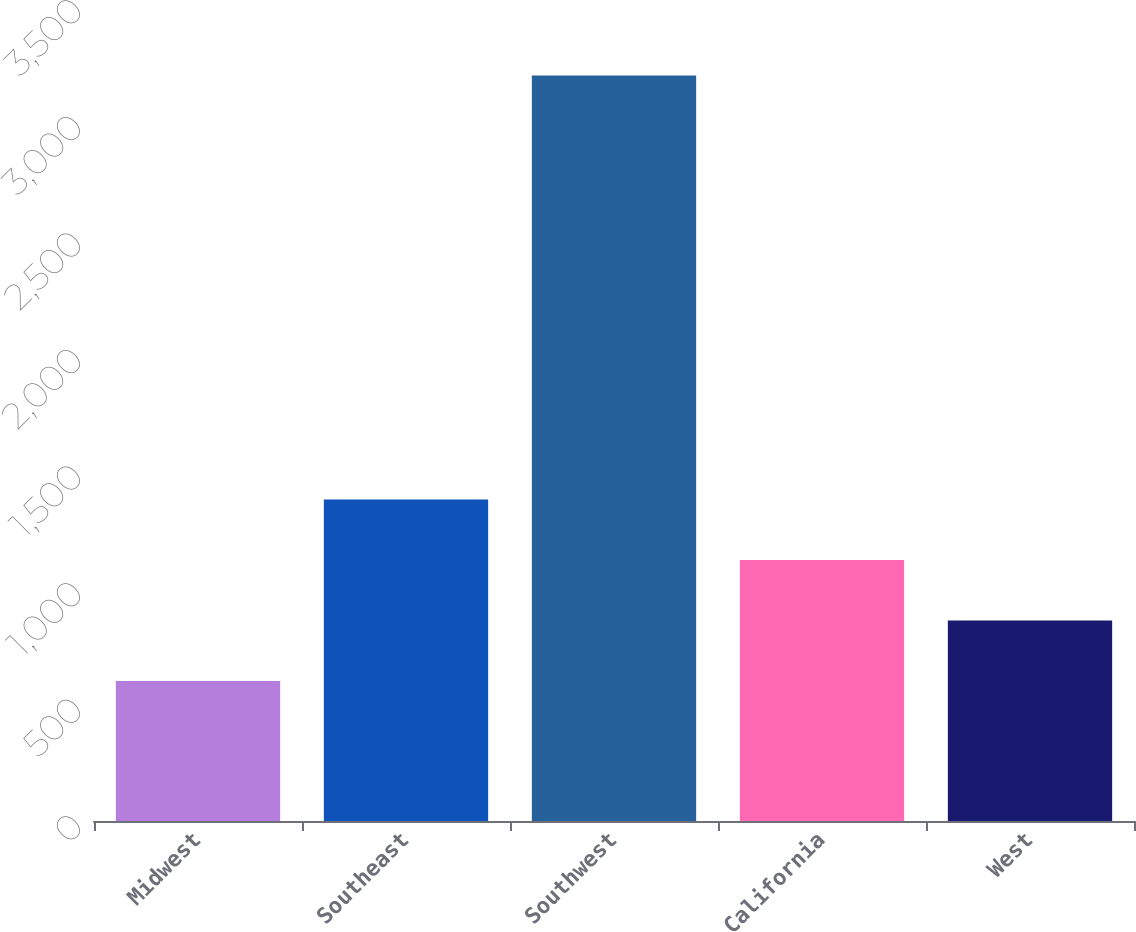<chart> <loc_0><loc_0><loc_500><loc_500><bar_chart><fcel>Midwest<fcel>Southeast<fcel>Southwest<fcel>California<fcel>West<nl><fcel>600<fcel>1379.4<fcel>3198<fcel>1119.6<fcel>859.8<nl></chart> 